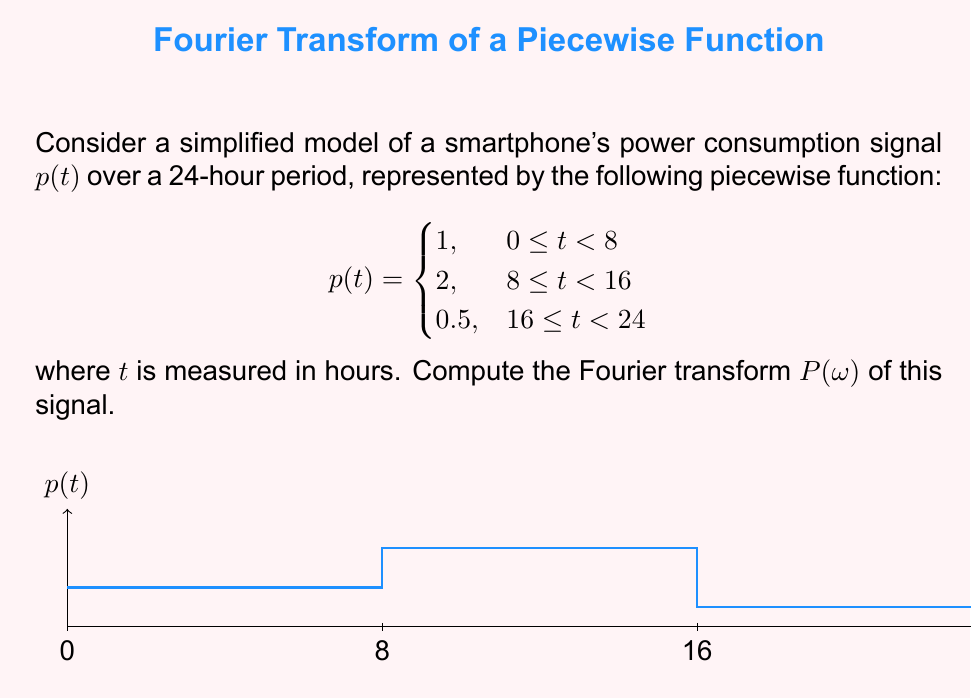Provide a solution to this math problem. To compute the Fourier transform of the given power consumption signal, we'll follow these steps:

1) The Fourier transform is defined as:

   $$P(\omega) = \int_{-\infty}^{\infty} p(t) e^{-i\omega t} dt$$

2) For our piecewise function, we need to split the integral:

   $$P(\omega) = \int_0^8 1 \cdot e^{-i\omega t} dt + \int_8^{16} 2 \cdot e^{-i\omega t} dt + \int_{16}^{24} 0.5 \cdot e^{-i\omega t} dt$$

3) Let's solve each integral separately:

   For $I_1 = \int_0^8 e^{-i\omega t} dt$:
   $$I_1 = \left[-\frac{1}{i\omega}e^{-i\omega t}\right]_0^8 = -\frac{1}{i\omega}(e^{-8i\omega} - 1)$$

   For $I_2 = \int_8^{16} 2e^{-i\omega t} dt$:
   $$I_2 = \left[-\frac{2}{i\omega}e^{-i\omega t}\right]_8^{16} = -\frac{2}{i\omega}(e^{-16i\omega} - e^{-8i\omega})$$

   For $I_3 = \int_{16}^{24} 0.5e^{-i\omega t} dt$:
   $$I_3 = \left[-\frac{0.5}{i\omega}e^{-i\omega t}\right]_{16}^{24} = -\frac{0.5}{i\omega}(e^{-24i\omega} - e^{-16i\omega})$$

4) Sum up all parts:

   $$P(\omega) = I_1 + I_2 + I_3$$

   $$P(\omega) = -\frac{1}{i\omega}(e^{-8i\omega} - 1) - \frac{2}{i\omega}(e^{-16i\omega} - e^{-8i\omega}) - \frac{0.5}{i\omega}(e^{-24i\omega} - e^{-16i\omega})$$

5) Simplify:

   $$P(\omega) = \frac{1}{i\omega}(1 - e^{-8i\omega} + 2e^{-8i\omega} - 2e^{-16i\omega} + 0.5e^{-16i\omega} - 0.5e^{-24i\omega})$$

   $$P(\omega) = \frac{1}{i\omega}(1 + e^{-8i\omega} - 1.5e^{-16i\omega} - 0.5e^{-24i\omega})$$

This is the Fourier transform of the given power consumption signal.
Answer: $$P(\omega) = \frac{1}{i\omega}(1 + e^{-8i\omega} - 1.5e^{-16i\omega} - 0.5e^{-24i\omega})$$ 